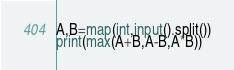<code> <loc_0><loc_0><loc_500><loc_500><_Python_>A,B=map(int,input().split())
print(max(A+B,A-B,A*B))</code> 